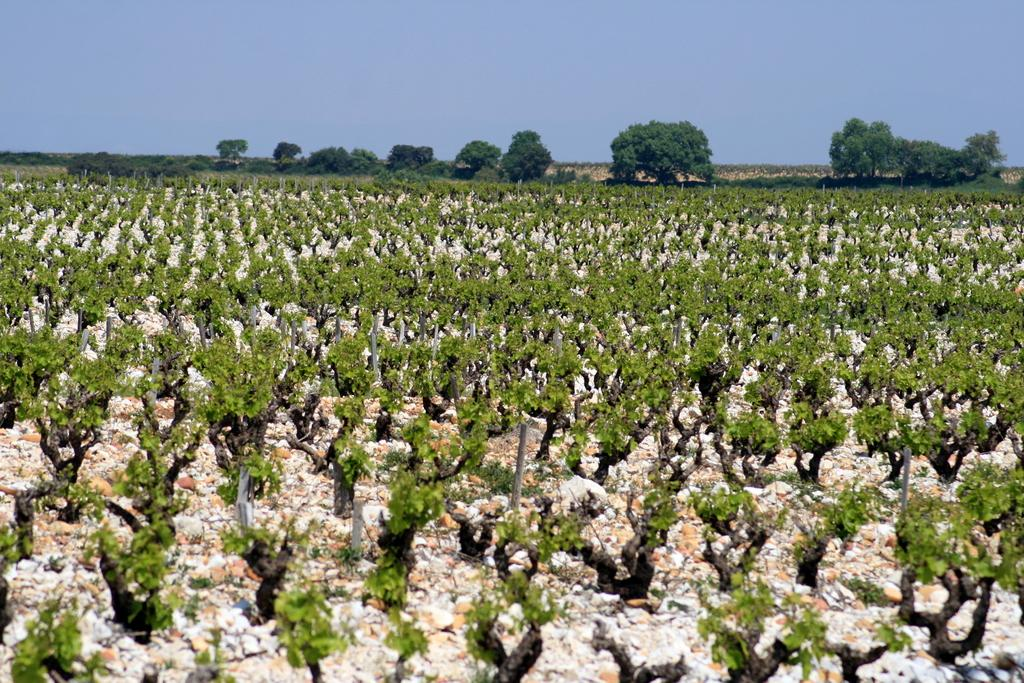What is located in the middle of the image? There are plants in the middle of the image. What can be seen at the top of the image? There are trees and the sky visible at the top of the image. Can you tell me how many gold spots are on the horse in the image? There is no horse present in the image, and therefore no gold spots can be observed. 